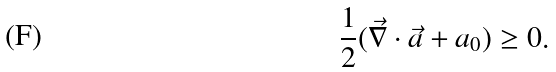<formula> <loc_0><loc_0><loc_500><loc_500>\frac { 1 } { 2 } ( \vec { \nabla } \cdot \vec { a } + a _ { 0 } ) \geq 0 .</formula> 